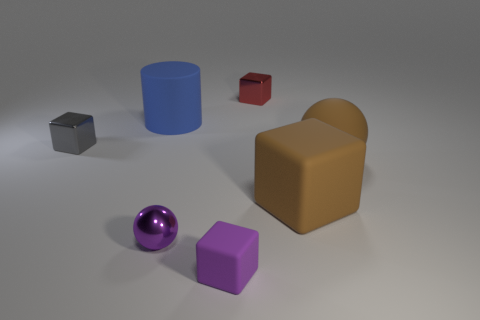Is the number of big yellow rubber blocks less than the number of big balls?
Offer a very short reply. Yes. What is the shape of the big matte object that is on the right side of the large blue rubber cylinder and on the left side of the brown matte ball?
Provide a succinct answer. Cube. How many big yellow metallic objects are there?
Offer a terse response. 0. The sphere that is left of the metallic thing behind the cube that is left of the tiny purple ball is made of what material?
Keep it short and to the point. Metal. How many tiny balls are left of the large object behind the tiny gray object?
Provide a short and direct response. 0. What color is the big rubber object that is the same shape as the small red shiny object?
Your answer should be compact. Brown. Is the material of the small red thing the same as the large sphere?
Offer a very short reply. No. How many spheres are blue rubber things or tiny rubber objects?
Give a very brief answer. 0. There is a metallic cube that is to the right of the matte object behind the shiny object left of the big blue matte object; what is its size?
Offer a very short reply. Small. The brown matte thing that is the same shape as the red object is what size?
Provide a short and direct response. Large. 